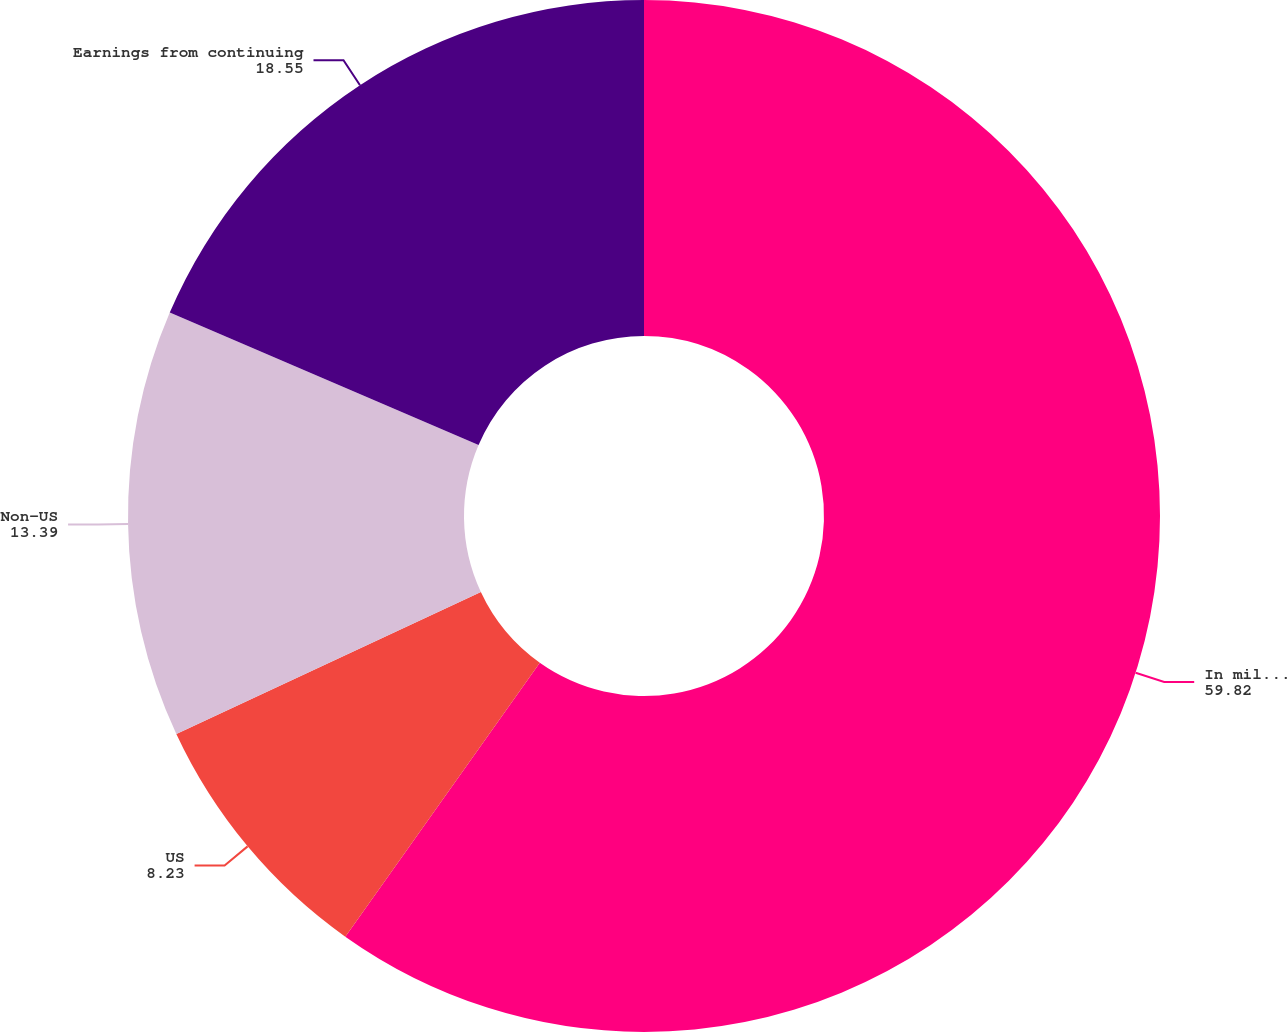Convert chart to OTSL. <chart><loc_0><loc_0><loc_500><loc_500><pie_chart><fcel>In millions<fcel>US<fcel>Non-US<fcel>Earnings from continuing<nl><fcel>59.82%<fcel>8.23%<fcel>13.39%<fcel>18.55%<nl></chart> 